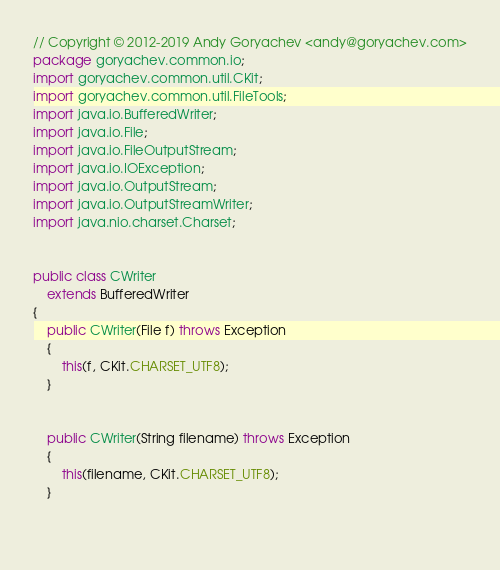Convert code to text. <code><loc_0><loc_0><loc_500><loc_500><_Java_>// Copyright © 2012-2019 Andy Goryachev <andy@goryachev.com>
package goryachev.common.io;
import goryachev.common.util.CKit;
import goryachev.common.util.FileTools;
import java.io.BufferedWriter;
import java.io.File;
import java.io.FileOutputStream;
import java.io.IOException;
import java.io.OutputStream;
import java.io.OutputStreamWriter;
import java.nio.charset.Charset;


public class CWriter
	extends BufferedWriter
{
	public CWriter(File f) throws Exception
	{
		this(f, CKit.CHARSET_UTF8);
	}
	
	
	public CWriter(String filename) throws Exception
	{
		this(filename, CKit.CHARSET_UTF8);
	}
	
	</code> 